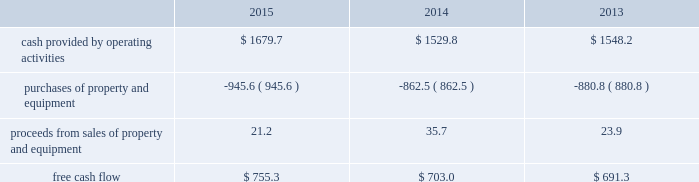Financial assurance we must provide financial assurance to governmental agencies and a variety of other entities under applicable environmental regulations relating to our landfill operations for capping , closure and post-closure costs , and related to our performance under certain collection , landfill and transfer station contracts .
We satisfy these financial assurance requirements by providing surety bonds , letters of credit , or insurance policies ( financial assurance instruments ) , or trust deposits , which are included in restricted cash and marketable securities and other assets in our consolidated balance sheets .
The amount of the financial assurance requirements for capping , closure and post-closure costs is determined by applicable state environmental regulations .
The financial assurance requirements for capping , closure and post-closure costs may be associated with a portion of the landfill or the entire landfill .
Generally , states require a third-party engineering specialist to determine the estimated capping , closure and post-closure costs that are used to determine the required amount of financial assurance for a landfill .
The amount of financial assurance required can , and generally will , differ from the obligation determined and recorded under u.s .
Gaap .
The amount of the financial assurance requirements related to contract performance varies by contract .
Additionally , we must provide financial assurance for our insurance program and collateral for certain performance obligations .
We do not expect a material increase in financial assurance requirements during 2016 , although the mix of financial assurance instruments may change .
These financial assurance instruments are issued in the normal course of business and are not considered indebtedness .
Because we currently have no liability for the financial assurance instruments , they are not reflected in our consolidated balance sheets ; however , we record capping , closure and post-closure liabilities and insurance liabilities as they are incurred .
Off-balance sheet arrangements we have no off-balance sheet debt or similar obligations , other than operating leases and financial assurances , which are not classified as debt .
We have no transactions or obligations with related parties that are not disclosed , consolidated into or reflected in our reported financial position or results of operations .
We have not guaranteed any third-party debt .
Free cash flow we define free cash flow , which is not a measure determined in accordance with u.s .
Gaap , as cash provided by operating activities less purchases of property and equipment , plus proceeds from sales of property and equipment , as presented in our consolidated statements of cash flows .
The table calculates our free cash flow for the years ended december 31 , 2015 , 2014 and 2013 ( in millions of dollars ) : .
For a discussion of the changes in the components of free cash flow , see our discussion regarding cash flows provided by operating activities and cash flows used in investing activities contained elsewhere in this management 2019s discussion and analysis of financial condition and results of operations. .
In 2015 what was the ratio of the cash provided by operating activities to the purchases of property and equipment? 
Rationale: for every 1.78 of cash provided by operating activities $ 1 was applied to the purchases of property and equipment
Computations: (1679.7 / 945.6)
Answer: 1.77633. 